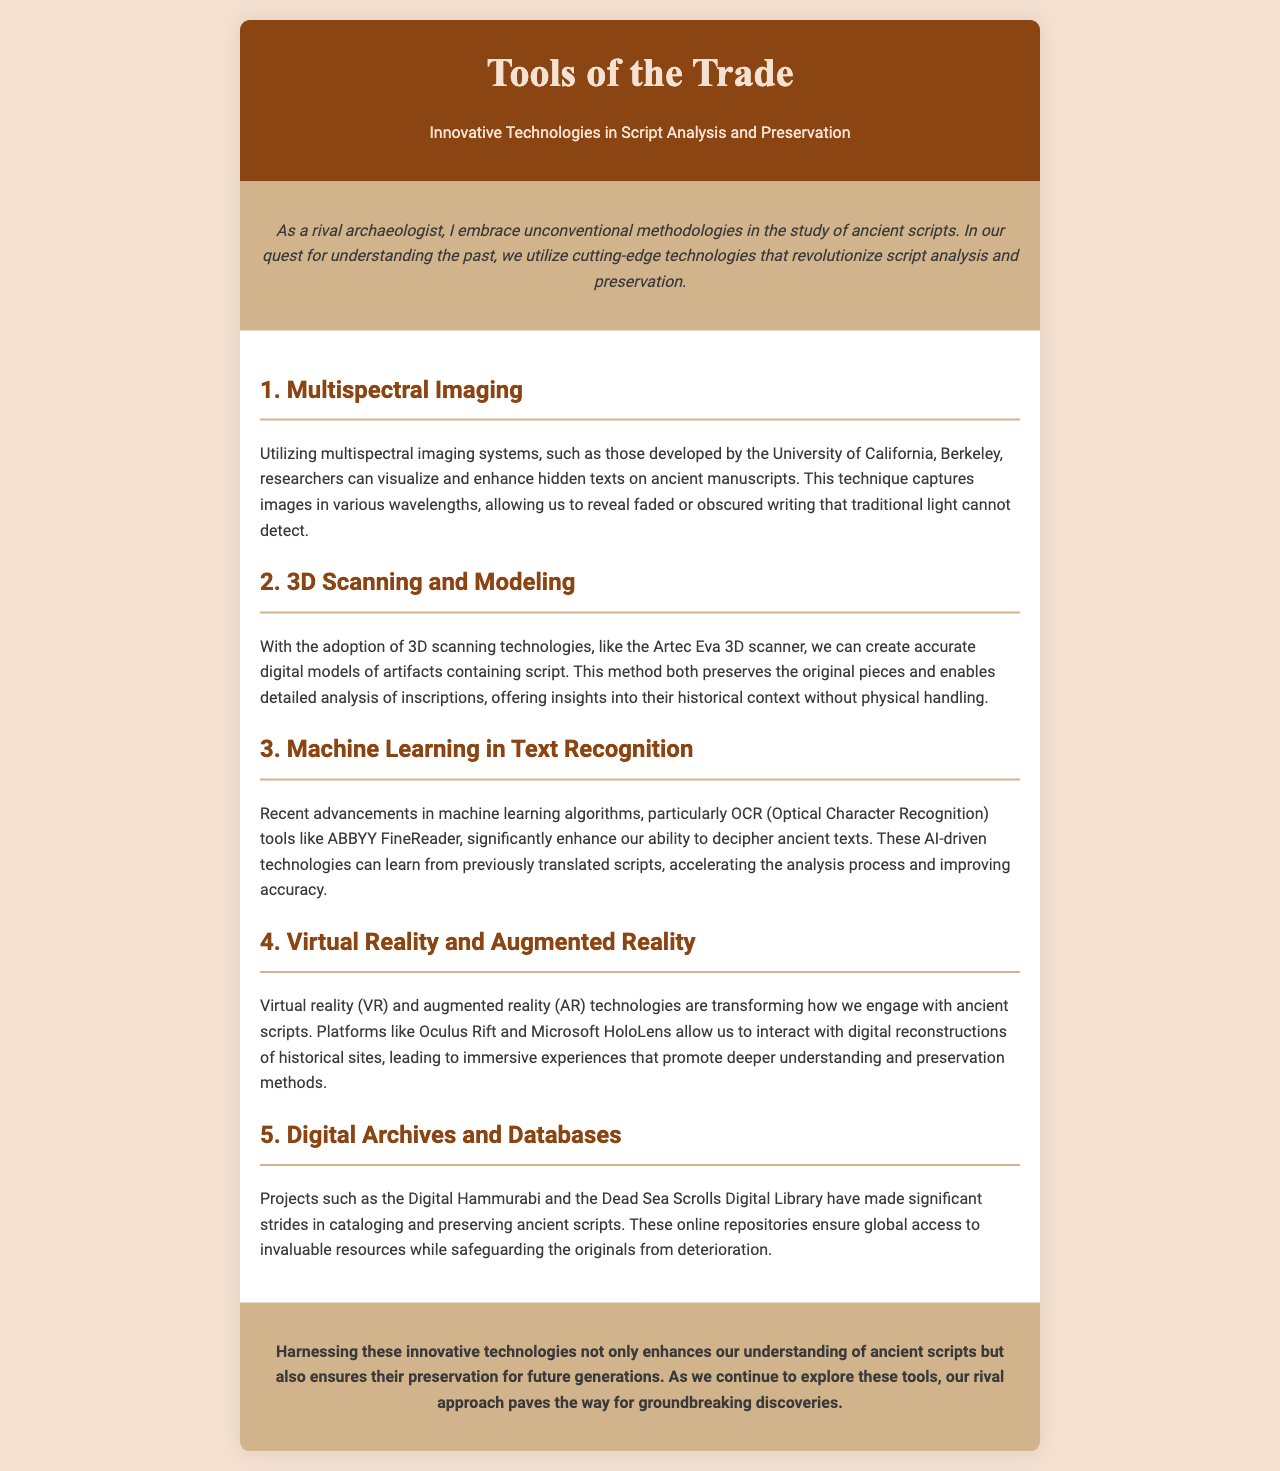What is the title of the brochure? The title is found in the header section, prominently displayed at the top of the document.
Answer: Tools of the Trade Who developed multispectral imaging systems mentioned in the document? The document specifies the University of California, Berkeley as the developer of these systems.
Answer: University of California, Berkeley What technology is used for creating digital models of artifacts? The document explicitly states the use of the Artec Eva 3D scanner for this purpose.
Answer: Artec Eva 3D scanner Which OCR tool is highlighted in the section on machine learning? The document identifies ABBYY FineReader as the OCR tool used for text recognition.
Answer: ABBYY FineReader What immersive technologies are discussed in the brochure? The text mentions virtual reality and augmented reality as the transformative technologies.
Answer: Virtual reality and augmented reality How do digital archives contribute to ancient script preservation? The document emphasizes that they ensure global access and protect originals from deterioration.
Answer: Global access and protection Name one project aimed at cataloging ancient scripts. The document lists the Digital Hammurabi as one example of a project working toward this goal.
Answer: Digital Hammurabi What is the main focus of the conclusion in the brochure? The conclusion emphasizes the importance of harnessing innovative technologies for understanding and preservation.
Answer: Enhancing understanding and preservation 